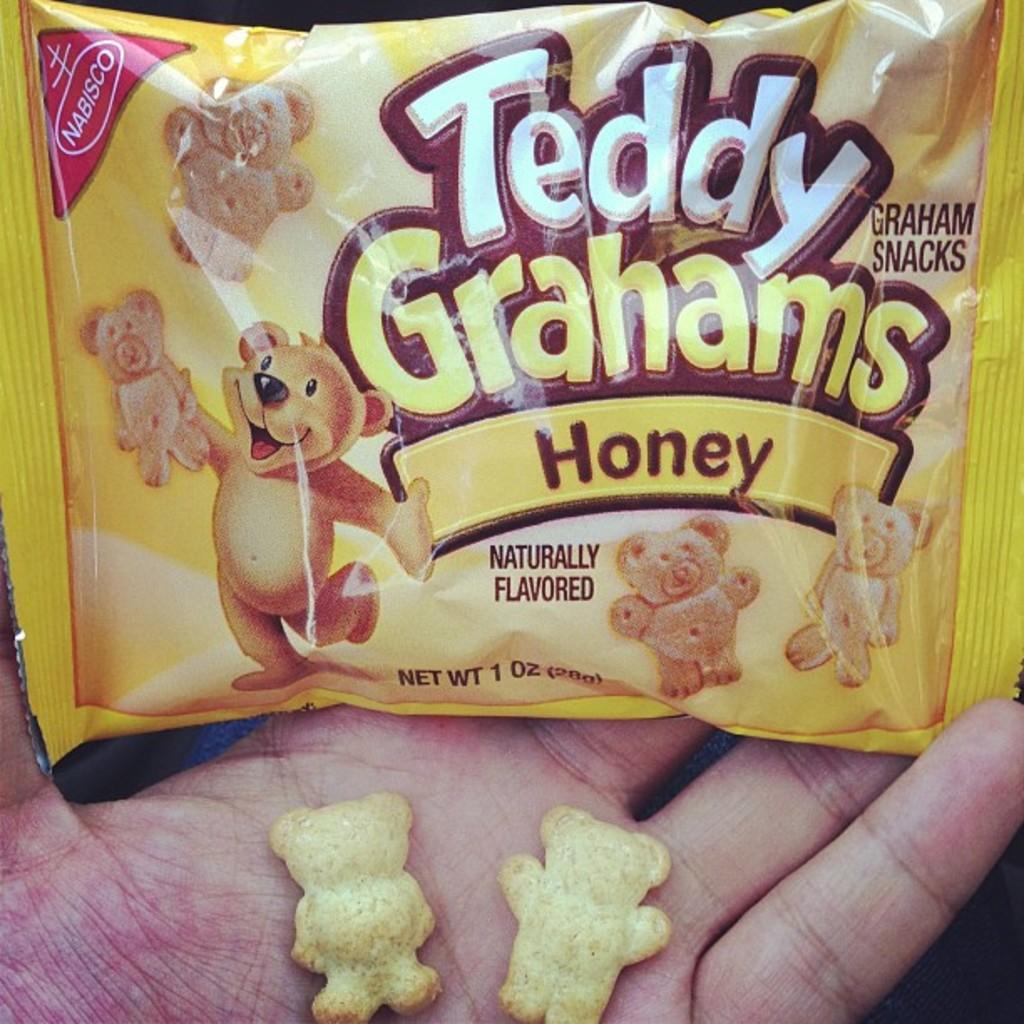What is the main object in the image? There is a teddy grahams packet in the image. Where is the teddy grahams packet located? The teddy grahams packet is on a hand. What is the price of the bucket in the image? There is no bucket present in the image, so it is not possible to determine its price. 